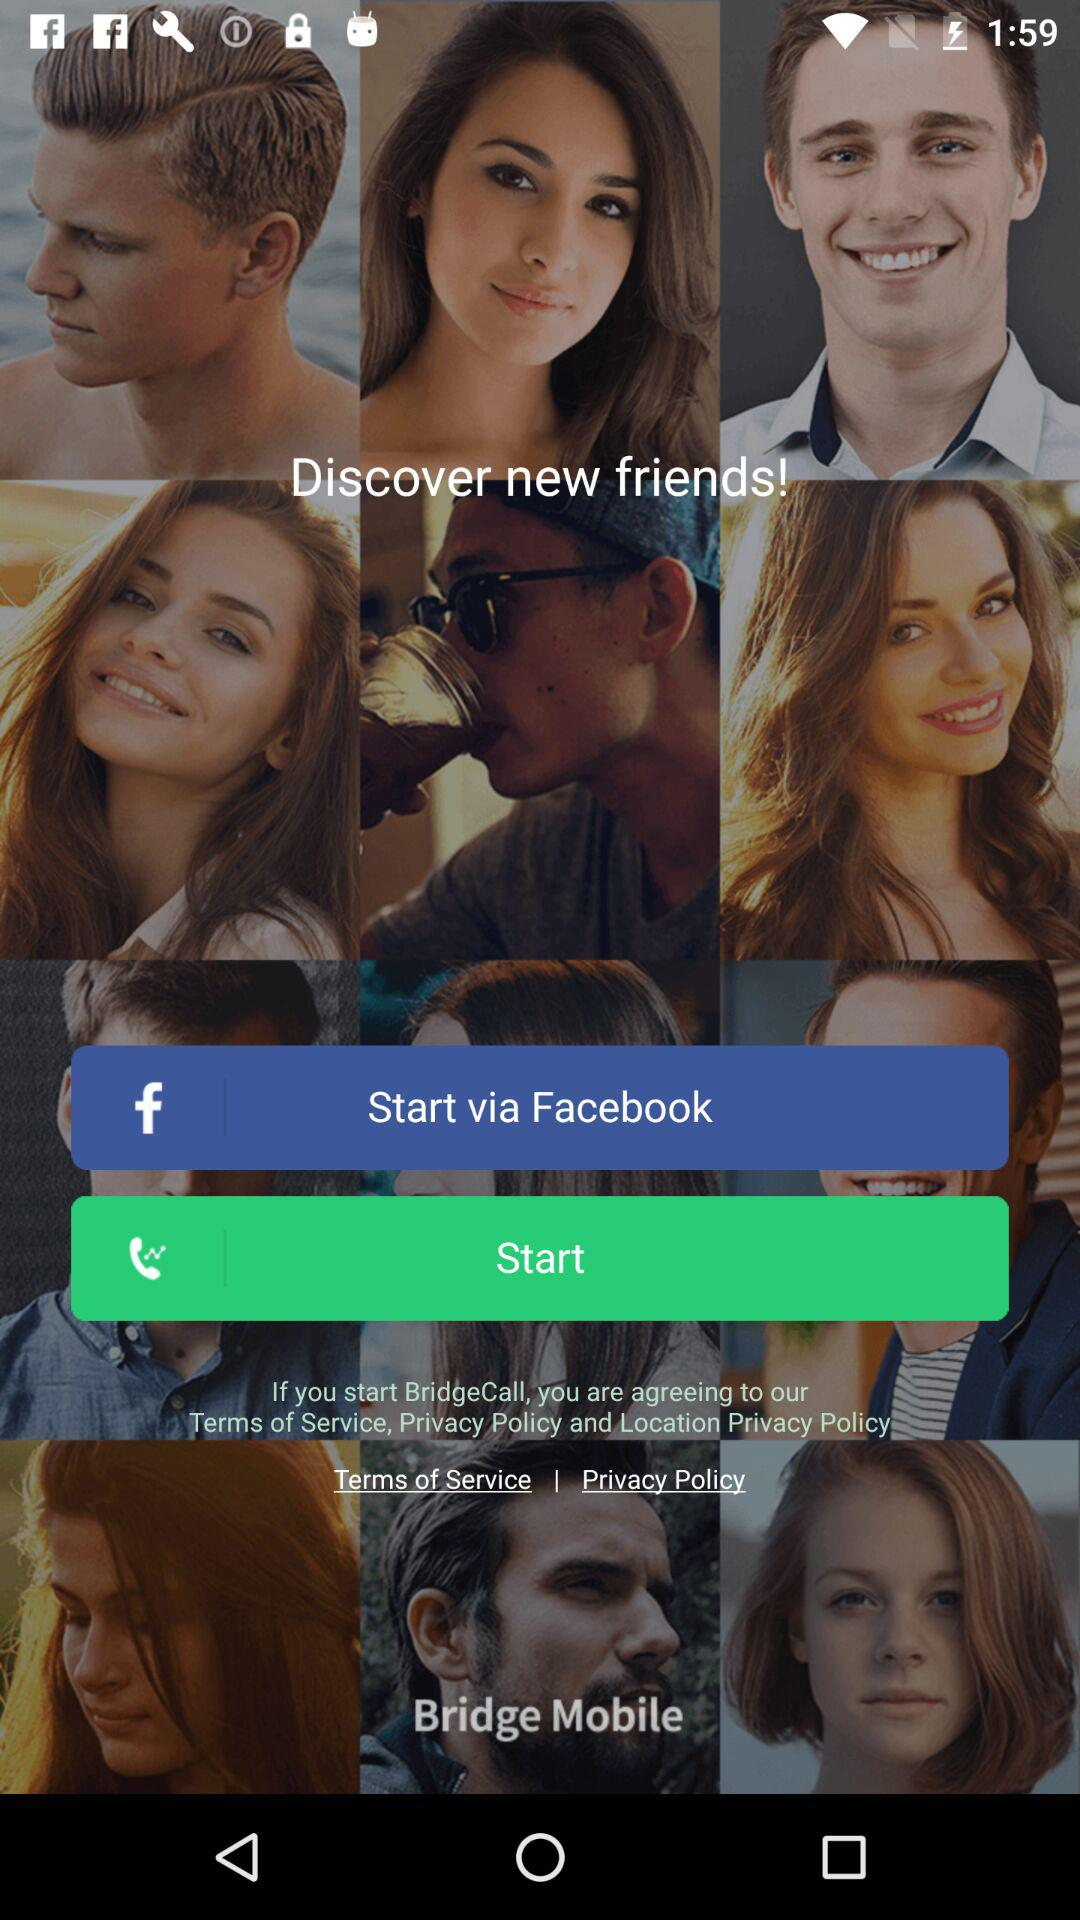What application can be used to start? The application is "Facebook". 